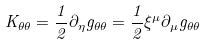<formula> <loc_0><loc_0><loc_500><loc_500>K _ { \theta \theta } = \frac { 1 } { 2 } \partial _ { \eta } g _ { \theta \theta } = \frac { 1 } { 2 } \xi ^ { \mu } \partial _ { \mu } g _ { \theta \theta }</formula> 